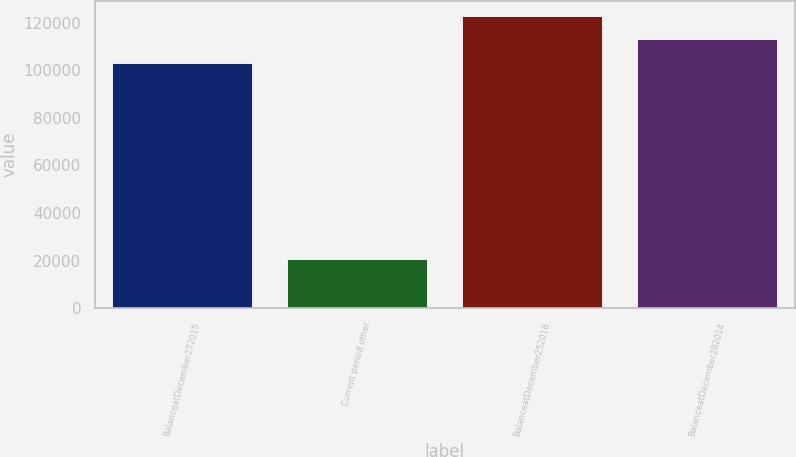<chart> <loc_0><loc_0><loc_500><loc_500><bar_chart><fcel>BalanceatDecember272015<fcel>Current period other<fcel>BalanceatDecember252016<fcel>BalanceatDecember282014<nl><fcel>102931<fcel>20829<fcel>122849<fcel>113092<nl></chart> 